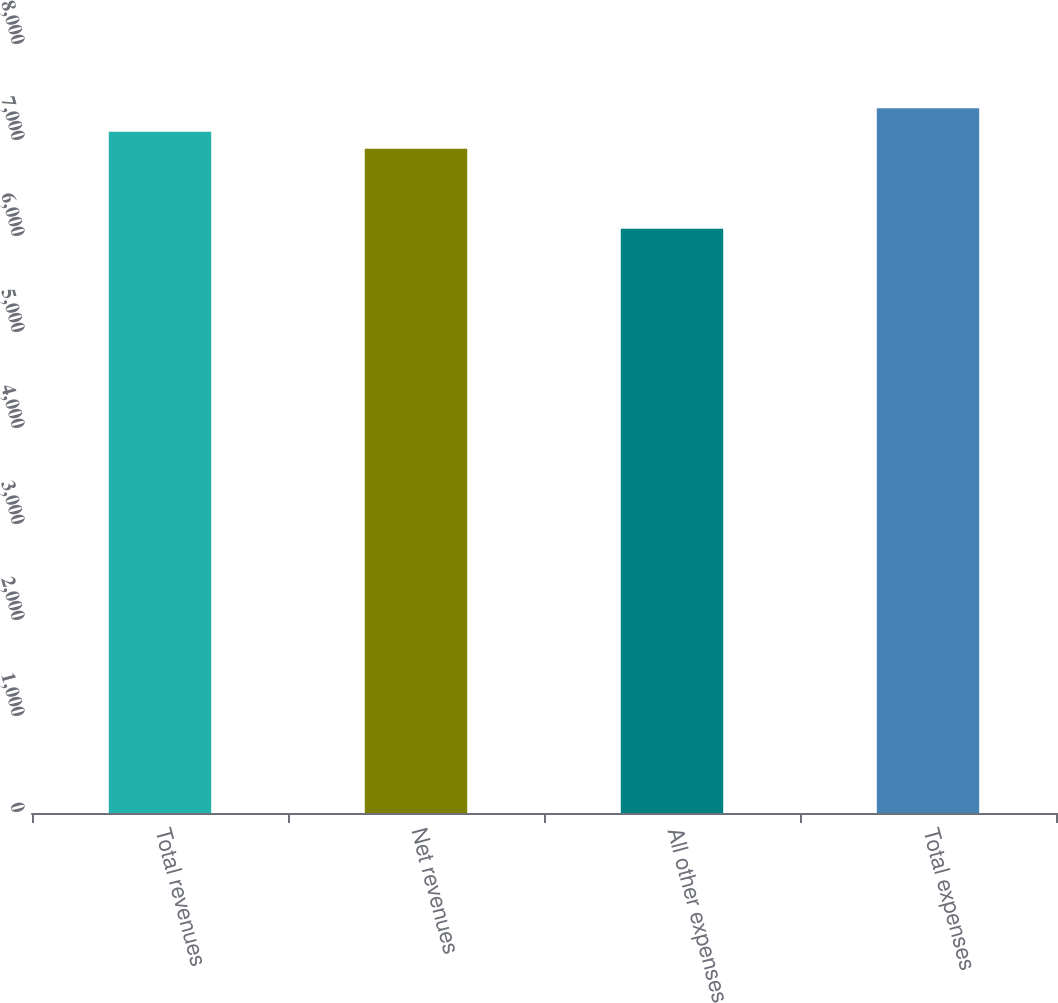Convert chart. <chart><loc_0><loc_0><loc_500><loc_500><bar_chart><fcel>Total revenues<fcel>Net revenues<fcel>All other expenses<fcel>Total expenses<nl><fcel>7097<fcel>6918<fcel>6085<fcel>7341<nl></chart> 